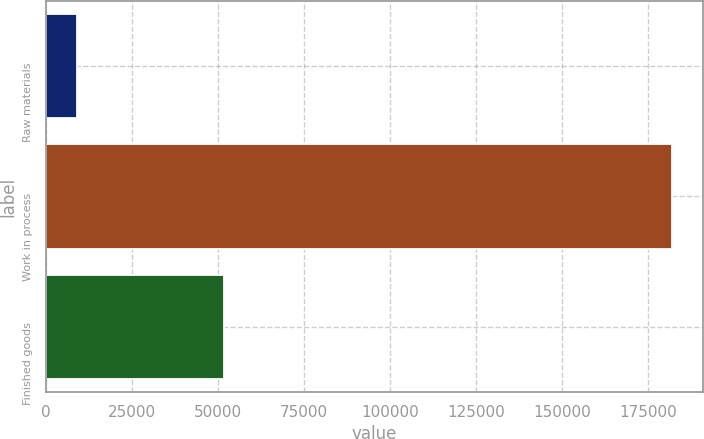Convert chart. <chart><loc_0><loc_0><loc_500><loc_500><bar_chart><fcel>Raw materials<fcel>Work in process<fcel>Finished goods<nl><fcel>9020<fcel>181750<fcel>51564<nl></chart> 